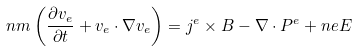<formula> <loc_0><loc_0><loc_500><loc_500>n m \left ( \frac { \partial { v } _ { e } } { \partial t } + { v } _ { e } \cdot \nabla { v } _ { e } \right ) = { j } ^ { e } \times { B } - \nabla \cdot { P } ^ { e } + n e { E }</formula> 